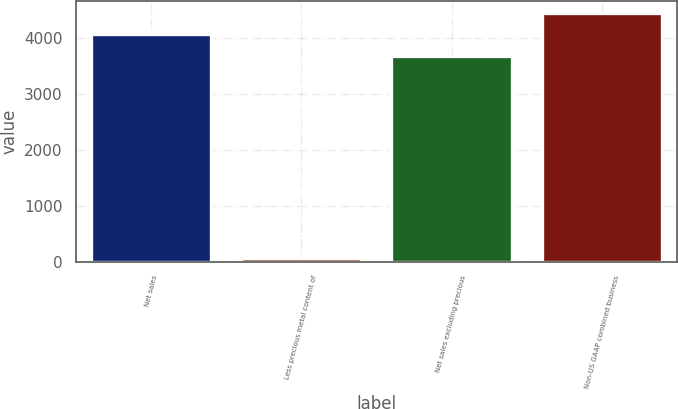Convert chart. <chart><loc_0><loc_0><loc_500><loc_500><bar_chart><fcel>Net sales<fcel>Less precious metal content of<fcel>Net sales excluding precious<fcel>Non-US GAAP combined business<nl><fcel>4060.04<fcel>64.3<fcel>3681<fcel>4439.08<nl></chart> 